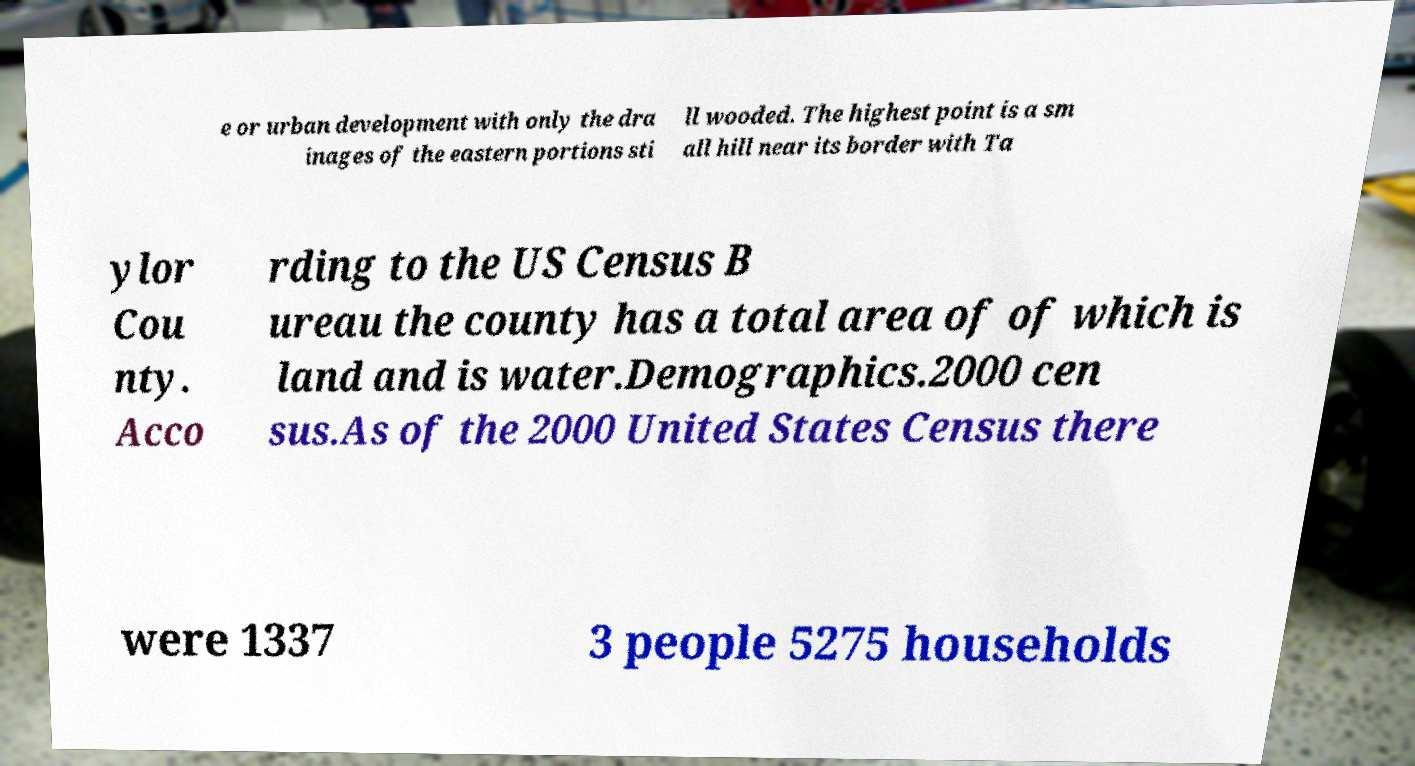I need the written content from this picture converted into text. Can you do that? e or urban development with only the dra inages of the eastern portions sti ll wooded. The highest point is a sm all hill near its border with Ta ylor Cou nty. Acco rding to the US Census B ureau the county has a total area of of which is land and is water.Demographics.2000 cen sus.As of the 2000 United States Census there were 1337 3 people 5275 households 